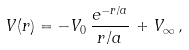<formula> <loc_0><loc_0><loc_500><loc_500>V ( r ) = - V _ { 0 } \, \frac { e ^ { - r / a } } { r / a } \, + V _ { \infty } \, ,</formula> 